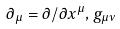<formula> <loc_0><loc_0><loc_500><loc_500>\partial _ { \mu } = \partial / \partial x ^ { \mu } , g _ { \mu \nu }</formula> 